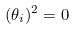Convert formula to latex. <formula><loc_0><loc_0><loc_500><loc_500>( \theta _ { i } ) ^ { 2 } = 0</formula> 